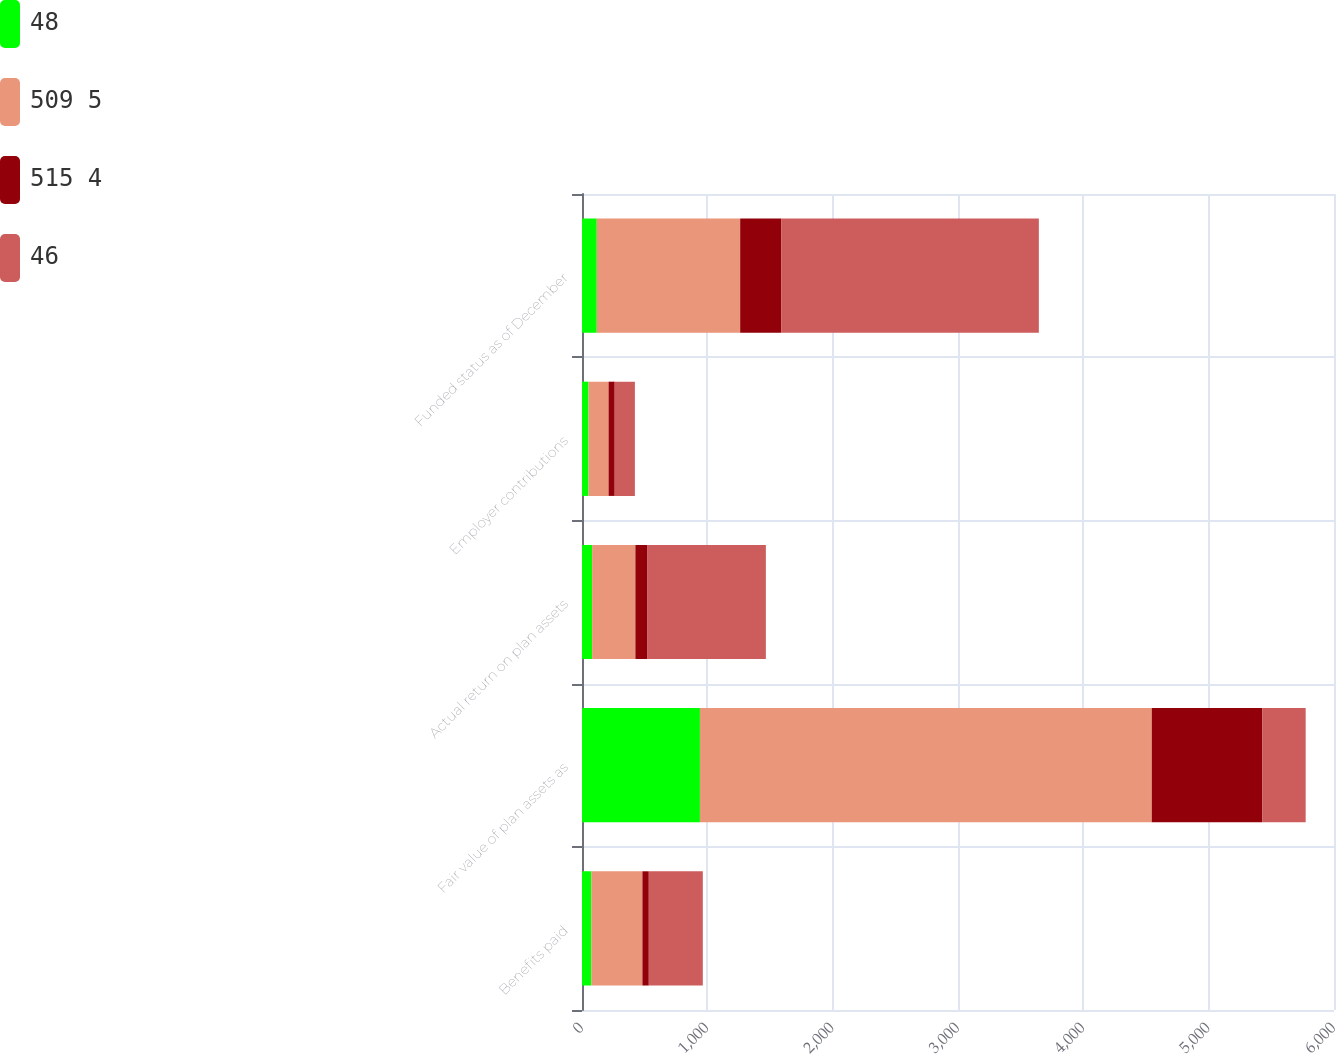Convert chart. <chart><loc_0><loc_0><loc_500><loc_500><stacked_bar_chart><ecel><fcel>Benefits paid<fcel>Fair value of plan assets as<fcel>Actual return on plan assets<fcel>Employer contributions<fcel>Funded status as of December<nl><fcel>48<fcel>75<fcel>941<fcel>81<fcel>52<fcel>118<nl><fcel>509 5<fcel>407<fcel>3605<fcel>345<fcel>160<fcel>1144<nl><fcel>515 4<fcel>51<fcel>883<fcel>97<fcel>49<fcel>327<nl><fcel>46<fcel>431<fcel>345<fcel>944<fcel>161<fcel>2056<nl></chart> 